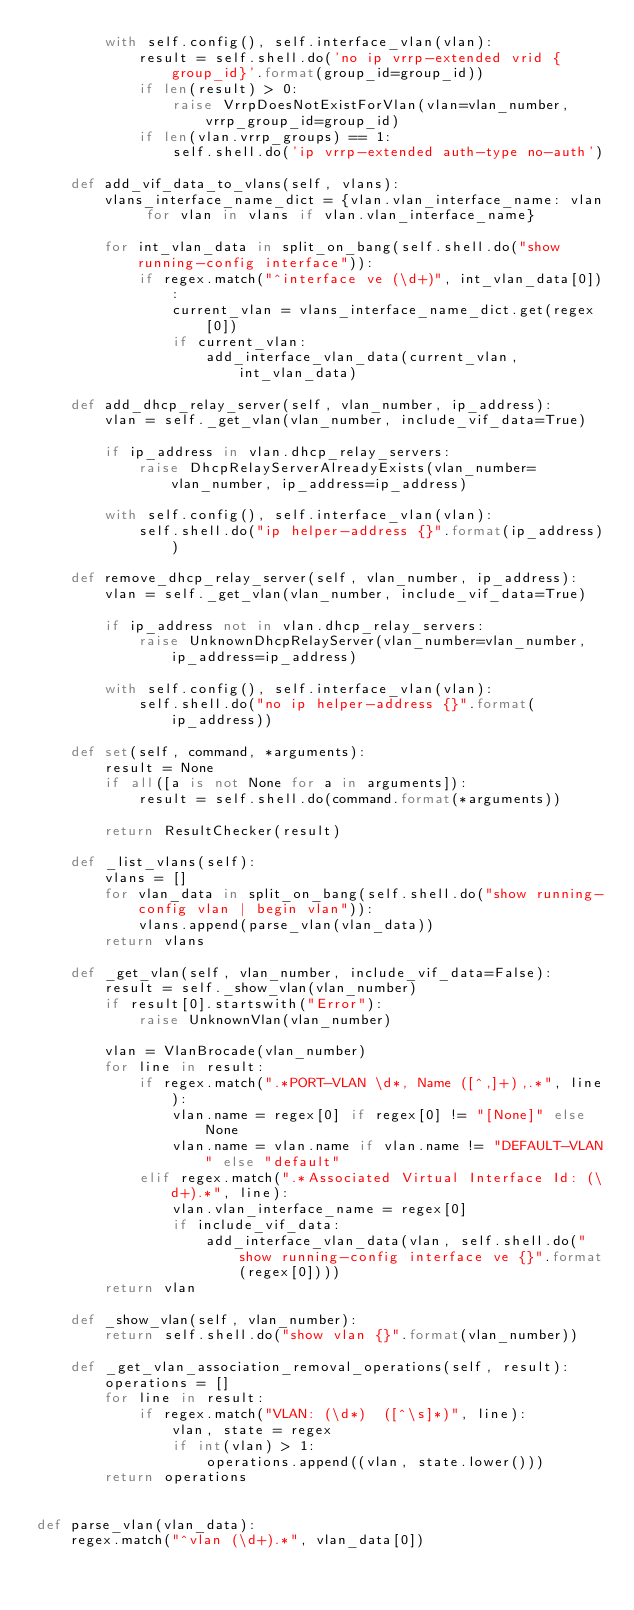<code> <loc_0><loc_0><loc_500><loc_500><_Python_>        with self.config(), self.interface_vlan(vlan):
            result = self.shell.do('no ip vrrp-extended vrid {group_id}'.format(group_id=group_id))
            if len(result) > 0:
                raise VrrpDoesNotExistForVlan(vlan=vlan_number, vrrp_group_id=group_id)
            if len(vlan.vrrp_groups) == 1:
                self.shell.do('ip vrrp-extended auth-type no-auth')

    def add_vif_data_to_vlans(self, vlans):
        vlans_interface_name_dict = {vlan.vlan_interface_name: vlan for vlan in vlans if vlan.vlan_interface_name}

        for int_vlan_data in split_on_bang(self.shell.do("show running-config interface")):
            if regex.match("^interface ve (\d+)", int_vlan_data[0]):
                current_vlan = vlans_interface_name_dict.get(regex[0])
                if current_vlan:
                    add_interface_vlan_data(current_vlan, int_vlan_data)

    def add_dhcp_relay_server(self, vlan_number, ip_address):
        vlan = self._get_vlan(vlan_number, include_vif_data=True)

        if ip_address in vlan.dhcp_relay_servers:
            raise DhcpRelayServerAlreadyExists(vlan_number=vlan_number, ip_address=ip_address)

        with self.config(), self.interface_vlan(vlan):
            self.shell.do("ip helper-address {}".format(ip_address))

    def remove_dhcp_relay_server(self, vlan_number, ip_address):
        vlan = self._get_vlan(vlan_number, include_vif_data=True)

        if ip_address not in vlan.dhcp_relay_servers:
            raise UnknownDhcpRelayServer(vlan_number=vlan_number, ip_address=ip_address)

        with self.config(), self.interface_vlan(vlan):
            self.shell.do("no ip helper-address {}".format(ip_address))

    def set(self, command, *arguments):
        result = None
        if all([a is not None for a in arguments]):
            result = self.shell.do(command.format(*arguments))

        return ResultChecker(result)

    def _list_vlans(self):
        vlans = []
        for vlan_data in split_on_bang(self.shell.do("show running-config vlan | begin vlan")):
            vlans.append(parse_vlan(vlan_data))
        return vlans

    def _get_vlan(self, vlan_number, include_vif_data=False):
        result = self._show_vlan(vlan_number)
        if result[0].startswith("Error"):
            raise UnknownVlan(vlan_number)

        vlan = VlanBrocade(vlan_number)
        for line in result:
            if regex.match(".*PORT-VLAN \d*, Name ([^,]+),.*", line):
                vlan.name = regex[0] if regex[0] != "[None]" else None
                vlan.name = vlan.name if vlan.name != "DEFAULT-VLAN" else "default"
            elif regex.match(".*Associated Virtual Interface Id: (\d+).*", line):
                vlan.vlan_interface_name = regex[0]
                if include_vif_data:
                    add_interface_vlan_data(vlan, self.shell.do("show running-config interface ve {}".format(regex[0])))
        return vlan

    def _show_vlan(self, vlan_number):
        return self.shell.do("show vlan {}".format(vlan_number))

    def _get_vlan_association_removal_operations(self, result):
        operations = []
        for line in result:
            if regex.match("VLAN: (\d*)  ([^\s]*)", line):
                vlan, state = regex
                if int(vlan) > 1:
                    operations.append((vlan, state.lower()))
        return operations


def parse_vlan(vlan_data):
    regex.match("^vlan (\d+).*", vlan_data[0])</code> 